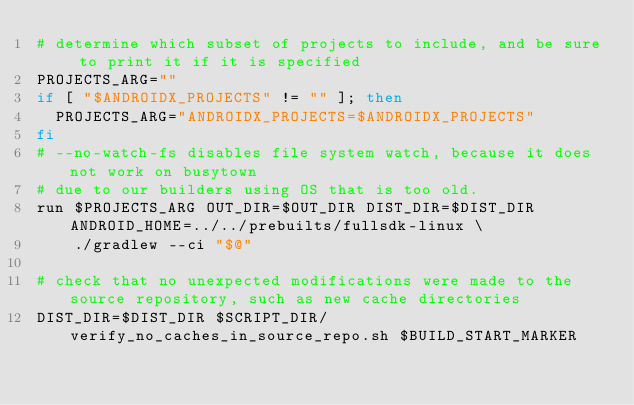Convert code to text. <code><loc_0><loc_0><loc_500><loc_500><_Bash_># determine which subset of projects to include, and be sure to print it if it is specified
PROJECTS_ARG=""
if [ "$ANDROIDX_PROJECTS" != "" ]; then
  PROJECTS_ARG="ANDROIDX_PROJECTS=$ANDROIDX_PROJECTS"
fi
# --no-watch-fs disables file system watch, because it does not work on busytown
# due to our builders using OS that is too old.
run $PROJECTS_ARG OUT_DIR=$OUT_DIR DIST_DIR=$DIST_DIR ANDROID_HOME=../../prebuilts/fullsdk-linux \
    ./gradlew --ci "$@"

# check that no unexpected modifications were made to the source repository, such as new cache directories
DIST_DIR=$DIST_DIR $SCRIPT_DIR/verify_no_caches_in_source_repo.sh $BUILD_START_MARKER
</code> 